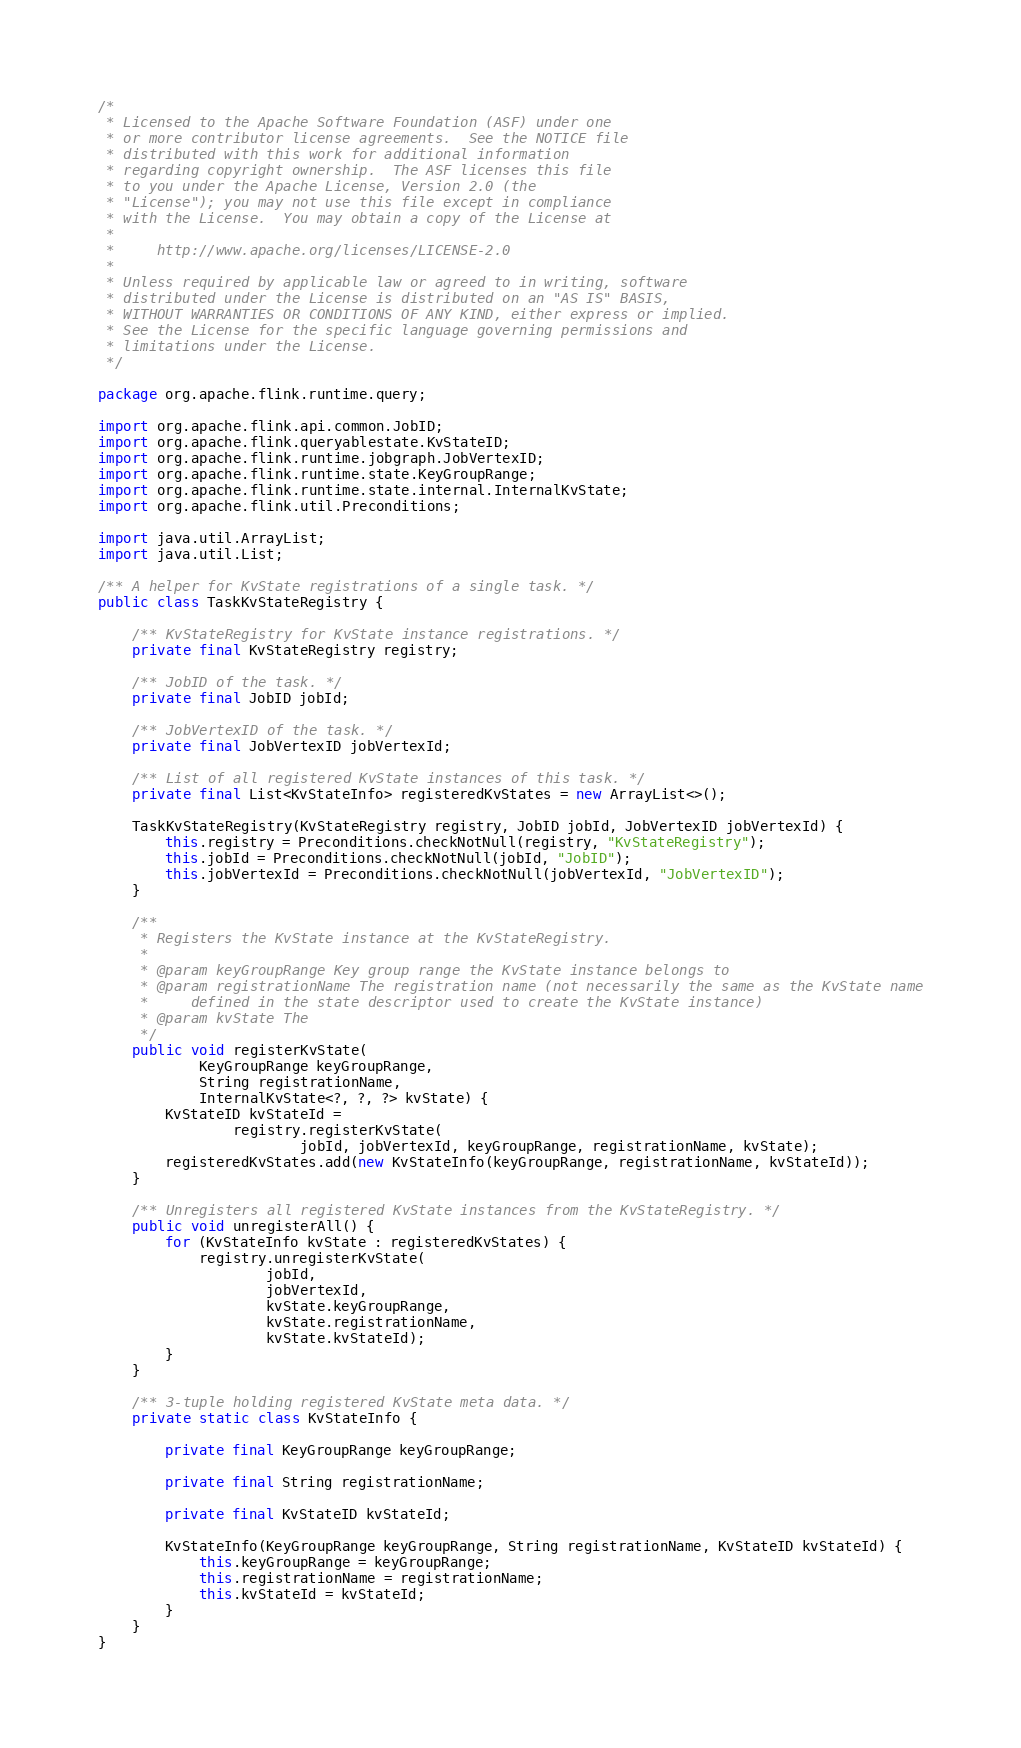<code> <loc_0><loc_0><loc_500><loc_500><_Java_>/*
 * Licensed to the Apache Software Foundation (ASF) under one
 * or more contributor license agreements.  See the NOTICE file
 * distributed with this work for additional information
 * regarding copyright ownership.  The ASF licenses this file
 * to you under the Apache License, Version 2.0 (the
 * "License"); you may not use this file except in compliance
 * with the License.  You may obtain a copy of the License at
 *
 *     http://www.apache.org/licenses/LICENSE-2.0
 *
 * Unless required by applicable law or agreed to in writing, software
 * distributed under the License is distributed on an "AS IS" BASIS,
 * WITHOUT WARRANTIES OR CONDITIONS OF ANY KIND, either express or implied.
 * See the License for the specific language governing permissions and
 * limitations under the License.
 */

package org.apache.flink.runtime.query;

import org.apache.flink.api.common.JobID;
import org.apache.flink.queryablestate.KvStateID;
import org.apache.flink.runtime.jobgraph.JobVertexID;
import org.apache.flink.runtime.state.KeyGroupRange;
import org.apache.flink.runtime.state.internal.InternalKvState;
import org.apache.flink.util.Preconditions;

import java.util.ArrayList;
import java.util.List;

/** A helper for KvState registrations of a single task. */
public class TaskKvStateRegistry {

    /** KvStateRegistry for KvState instance registrations. */
    private final KvStateRegistry registry;

    /** JobID of the task. */
    private final JobID jobId;

    /** JobVertexID of the task. */
    private final JobVertexID jobVertexId;

    /** List of all registered KvState instances of this task. */
    private final List<KvStateInfo> registeredKvStates = new ArrayList<>();

    TaskKvStateRegistry(KvStateRegistry registry, JobID jobId, JobVertexID jobVertexId) {
        this.registry = Preconditions.checkNotNull(registry, "KvStateRegistry");
        this.jobId = Preconditions.checkNotNull(jobId, "JobID");
        this.jobVertexId = Preconditions.checkNotNull(jobVertexId, "JobVertexID");
    }

    /**
     * Registers the KvState instance at the KvStateRegistry.
     *
     * @param keyGroupRange Key group range the KvState instance belongs to
     * @param registrationName The registration name (not necessarily the same as the KvState name
     *     defined in the state descriptor used to create the KvState instance)
     * @param kvState The
     */
    public void registerKvState(
            KeyGroupRange keyGroupRange,
            String registrationName,
            InternalKvState<?, ?, ?> kvState) {
        KvStateID kvStateId =
                registry.registerKvState(
                        jobId, jobVertexId, keyGroupRange, registrationName, kvState);
        registeredKvStates.add(new KvStateInfo(keyGroupRange, registrationName, kvStateId));
    }

    /** Unregisters all registered KvState instances from the KvStateRegistry. */
    public void unregisterAll() {
        for (KvStateInfo kvState : registeredKvStates) {
            registry.unregisterKvState(
                    jobId,
                    jobVertexId,
                    kvState.keyGroupRange,
                    kvState.registrationName,
                    kvState.kvStateId);
        }
    }

    /** 3-tuple holding registered KvState meta data. */
    private static class KvStateInfo {

        private final KeyGroupRange keyGroupRange;

        private final String registrationName;

        private final KvStateID kvStateId;

        KvStateInfo(KeyGroupRange keyGroupRange, String registrationName, KvStateID kvStateId) {
            this.keyGroupRange = keyGroupRange;
            this.registrationName = registrationName;
            this.kvStateId = kvStateId;
        }
    }
}
</code> 